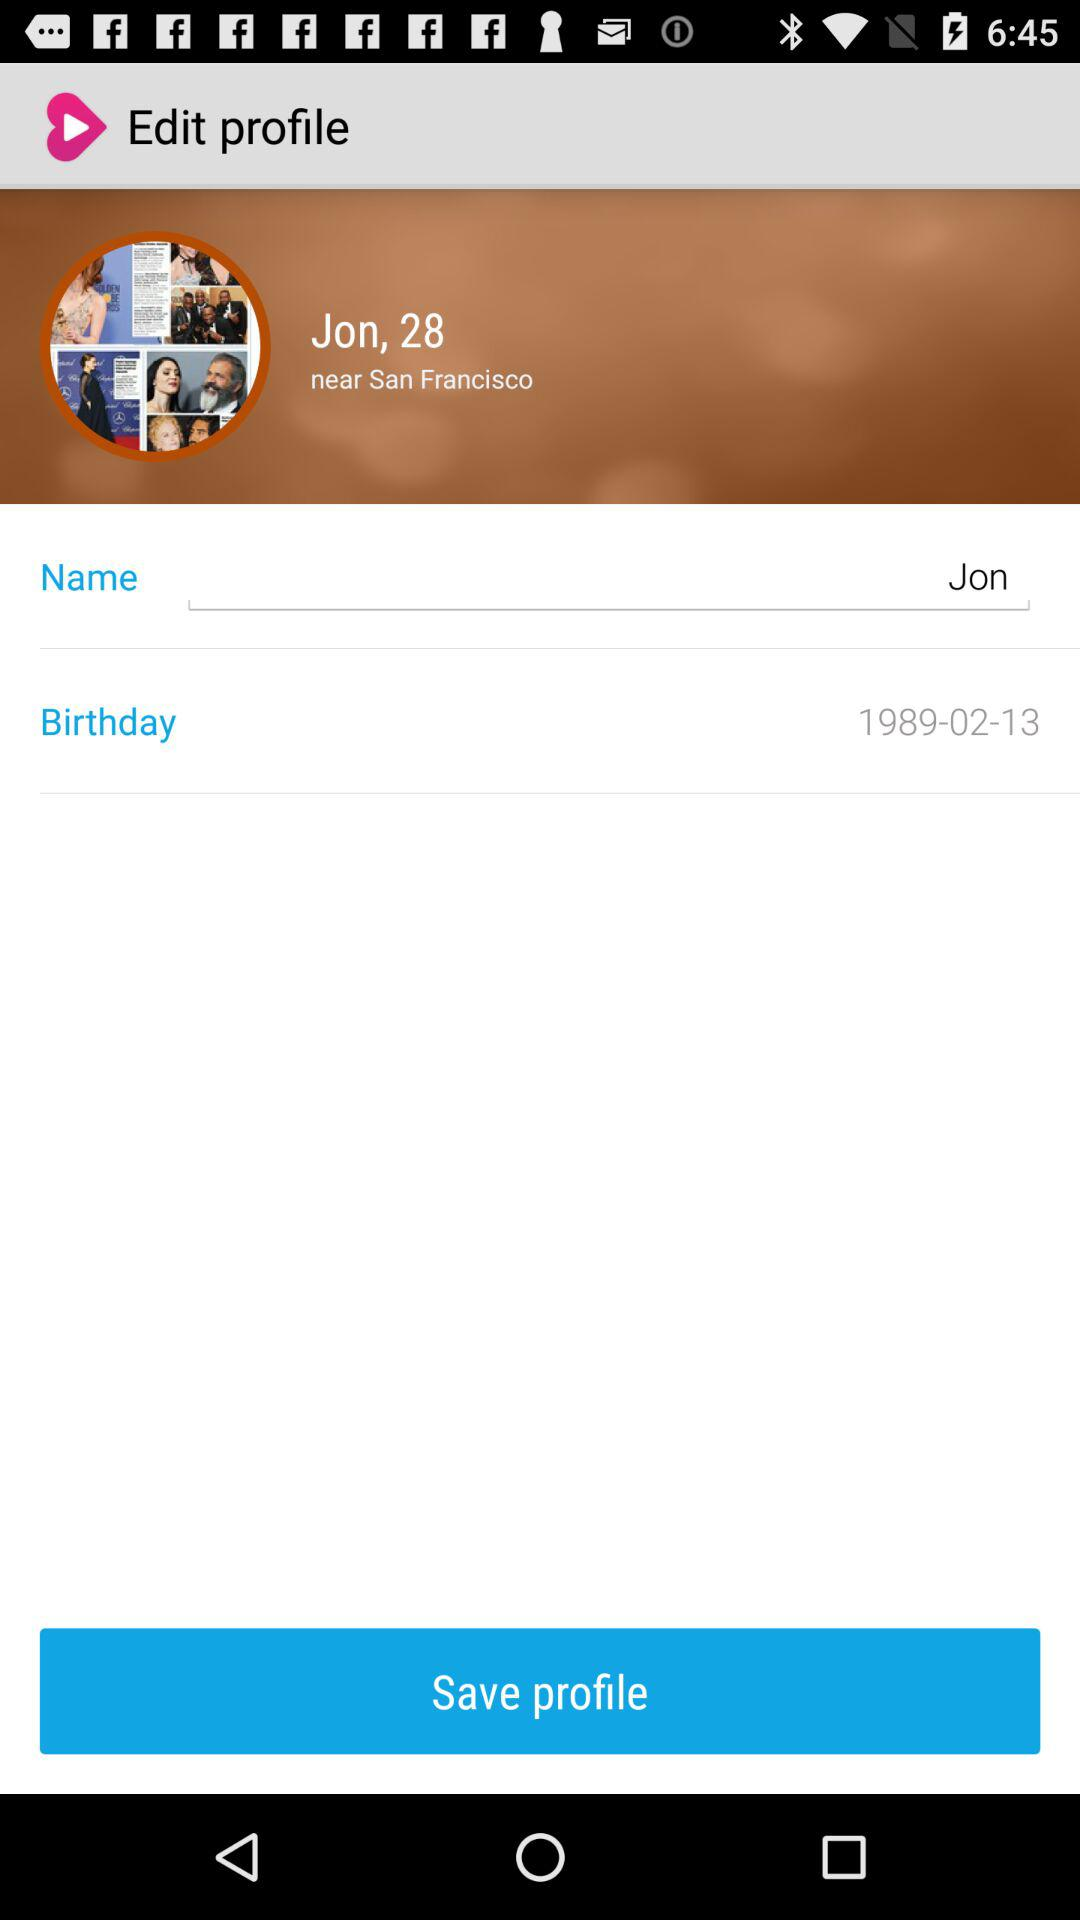What is the age? The age is 28. 